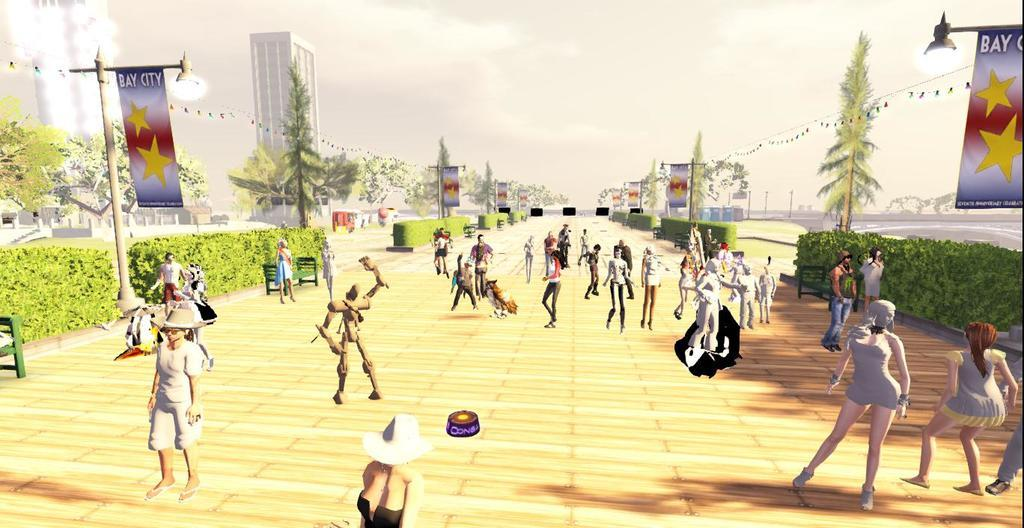Who or what can be seen in the image? There are people in the image. What type of seating is available in the image? There are benches in the image. What can be used for illumination in the image? There are lights in the image. What is attached to the poles in the image? There are banners on poles in the image. What type of vegetation is present in the image? There are plants in the image. What structure is visible in the background of the image? There is a building in the background of the image. What type of natural scenery is visible in the background of the image? There are trees in the background of the image. What is visible above the trees in the background of the image? The sky is visible in the background of the image. What type of brick is used to construct the tent in the image? There is no tent present in the image, and therefore no bricks are used for its construction. 